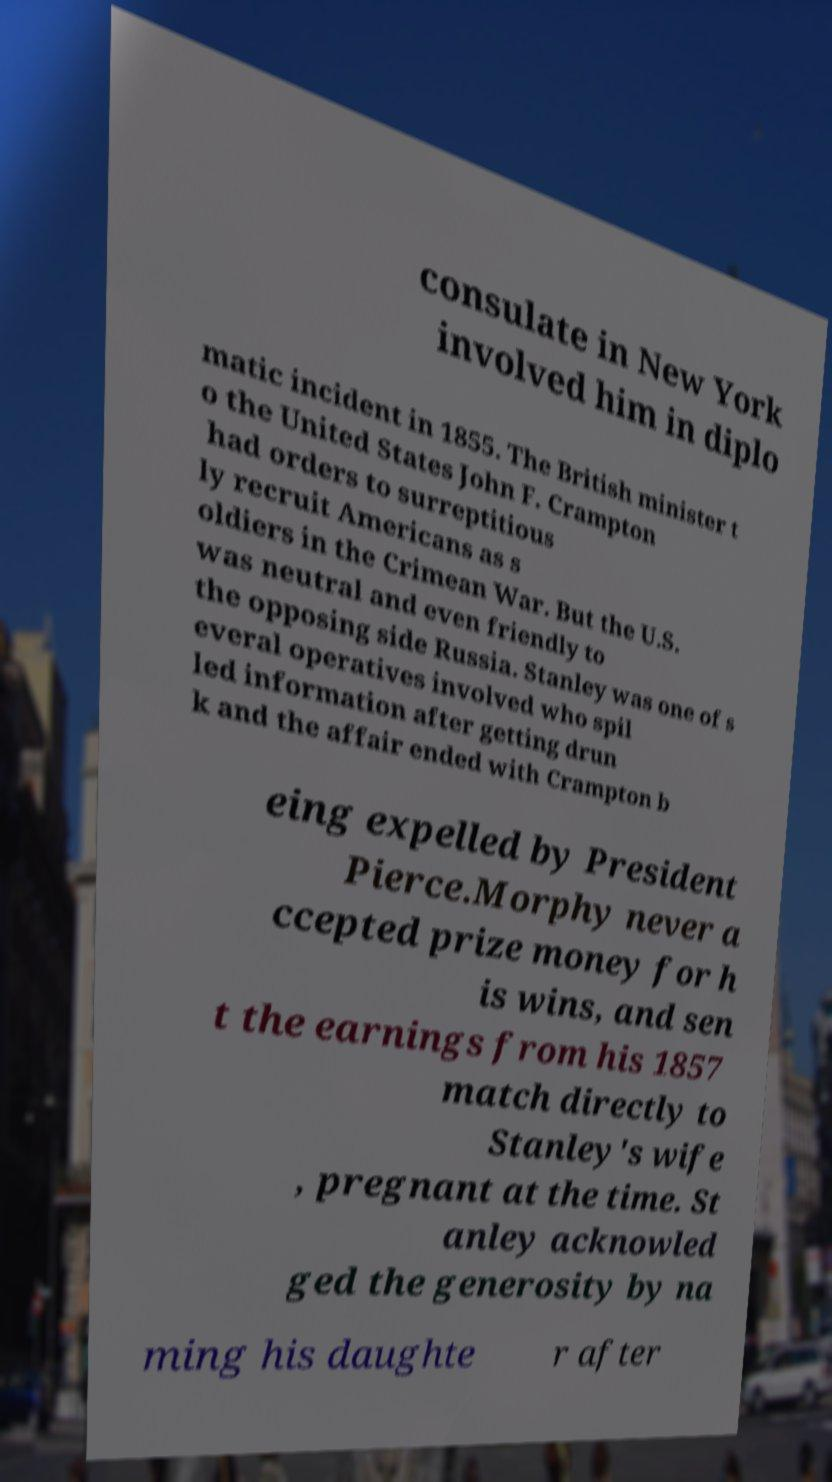For documentation purposes, I need the text within this image transcribed. Could you provide that? consulate in New York involved him in diplo matic incident in 1855. The British minister t o the United States John F. Crampton had orders to surreptitious ly recruit Americans as s oldiers in the Crimean War. But the U.S. was neutral and even friendly to the opposing side Russia. Stanley was one of s everal operatives involved who spil led information after getting drun k and the affair ended with Crampton b eing expelled by President Pierce.Morphy never a ccepted prize money for h is wins, and sen t the earnings from his 1857 match directly to Stanley's wife , pregnant at the time. St anley acknowled ged the generosity by na ming his daughte r after 